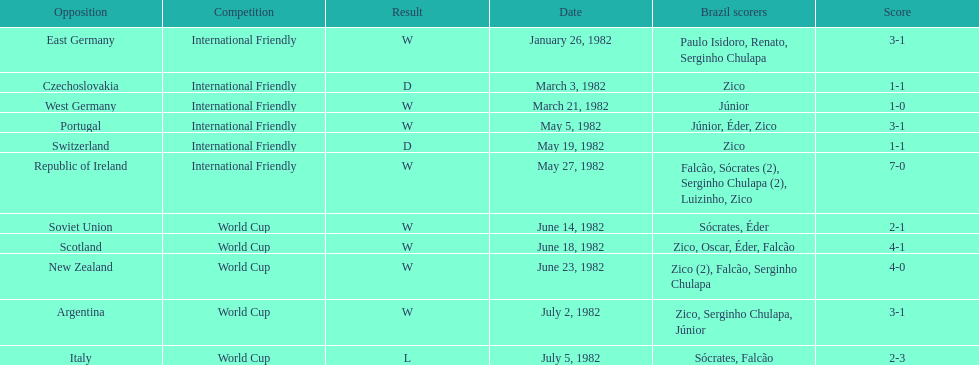Can you parse all the data within this table? {'header': ['Opposition', 'Competition', 'Result', 'Date', 'Brazil scorers', 'Score'], 'rows': [['East Germany', 'International Friendly', 'W', 'January 26, 1982', 'Paulo Isidoro, Renato, Serginho Chulapa', '3-1'], ['Czechoslovakia', 'International Friendly', 'D', 'March 3, 1982', 'Zico', '1-1'], ['West Germany', 'International Friendly', 'W', 'March 21, 1982', 'Júnior', '1-0'], ['Portugal', 'International Friendly', 'W', 'May 5, 1982', 'Júnior, Éder, Zico', '3-1'], ['Switzerland', 'International Friendly', 'D', 'May 19, 1982', 'Zico', '1-1'], ['Republic of Ireland', 'International Friendly', 'W', 'May 27, 1982', 'Falcão, Sócrates (2), Serginho Chulapa (2), Luizinho, Zico', '7-0'], ['Soviet Union', 'World Cup', 'W', 'June 14, 1982', 'Sócrates, Éder', '2-1'], ['Scotland', 'World Cup', 'W', 'June 18, 1982', 'Zico, Oscar, Éder, Falcão', '4-1'], ['New Zealand', 'World Cup', 'W', 'June 23, 1982', 'Zico (2), Falcão, Serginho Chulapa', '4-0'], ['Argentina', 'World Cup', 'W', 'July 2, 1982', 'Zico, Serginho Chulapa, Júnior', '3-1'], ['Italy', 'World Cup', 'L', 'July 5, 1982', 'Sócrates, Falcão', '2-3']]} Was the total goals scored on june 14, 1982 more than 6? No. 